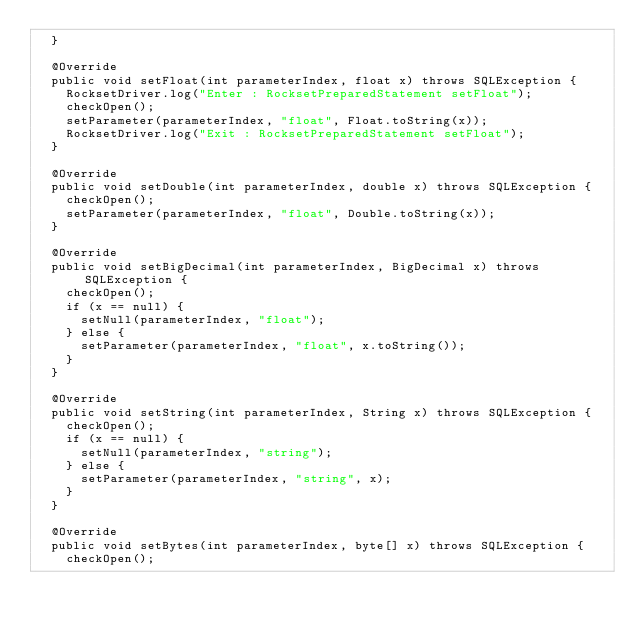Convert code to text. <code><loc_0><loc_0><loc_500><loc_500><_Java_>  }

  @Override
  public void setFloat(int parameterIndex, float x) throws SQLException {
    RocksetDriver.log("Enter : RocksetPreparedStatement setFloat");
    checkOpen();
    setParameter(parameterIndex, "float", Float.toString(x));
    RocksetDriver.log("Exit : RocksetPreparedStatement setFloat");
  }

  @Override
  public void setDouble(int parameterIndex, double x) throws SQLException {
    checkOpen();
    setParameter(parameterIndex, "float", Double.toString(x));
  }

  @Override
  public void setBigDecimal(int parameterIndex, BigDecimal x) throws SQLException {
    checkOpen();
    if (x == null) {
      setNull(parameterIndex, "float");
    } else {
      setParameter(parameterIndex, "float", x.toString());
    }
  }

  @Override
  public void setString(int parameterIndex, String x) throws SQLException {
    checkOpen();
    if (x == null) {
      setNull(parameterIndex, "string");
    } else {
      setParameter(parameterIndex, "string", x);
    }
  }

  @Override
  public void setBytes(int parameterIndex, byte[] x) throws SQLException {
    checkOpen();</code> 